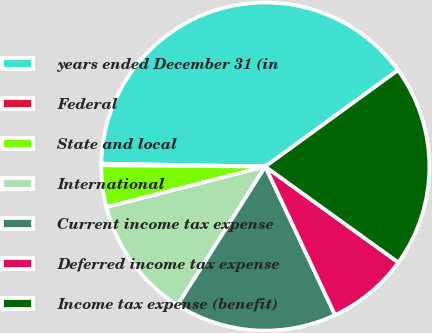Convert chart to OTSL. <chart><loc_0><loc_0><loc_500><loc_500><pie_chart><fcel>years ended December 31 (in<fcel>Federal<fcel>State and local<fcel>International<fcel>Current income tax expense<fcel>Deferred income tax expense<fcel>Income tax expense (benefit)<nl><fcel>39.72%<fcel>0.16%<fcel>4.11%<fcel>12.03%<fcel>15.98%<fcel>8.07%<fcel>19.94%<nl></chart> 